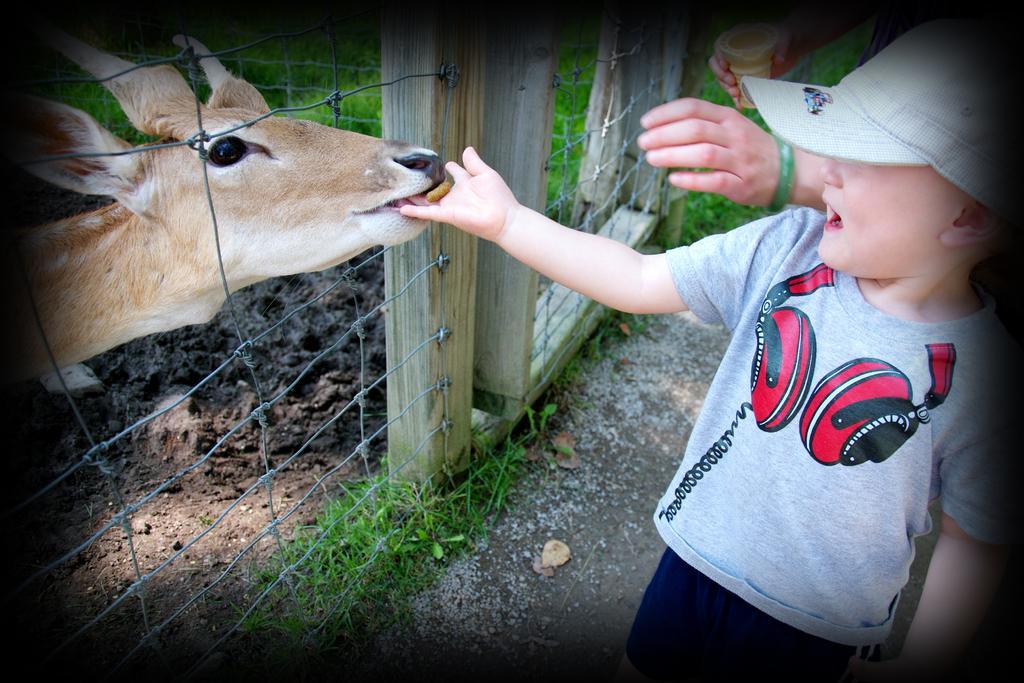Can you describe this image briefly? In the image we can see there is a kid standing and he is feeding deer. The deer is standing on the ground behind the iron fencing. The ground is covered with grass and there is a person holding juice glass in her hand. 